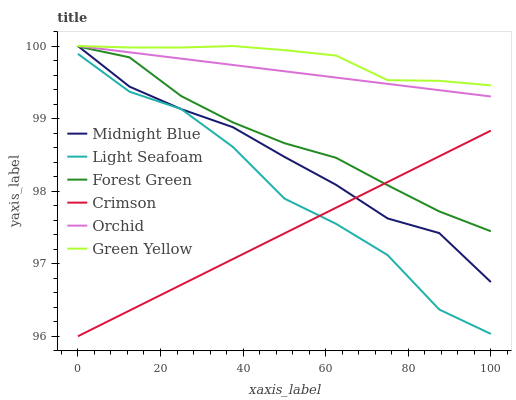Does Crimson have the minimum area under the curve?
Answer yes or no. Yes. Does Green Yellow have the maximum area under the curve?
Answer yes or no. Yes. Does Midnight Blue have the minimum area under the curve?
Answer yes or no. No. Does Midnight Blue have the maximum area under the curve?
Answer yes or no. No. Is Crimson the smoothest?
Answer yes or no. Yes. Is Light Seafoam the roughest?
Answer yes or no. Yes. Is Midnight Blue the smoothest?
Answer yes or no. No. Is Midnight Blue the roughest?
Answer yes or no. No. Does Crimson have the lowest value?
Answer yes or no. Yes. Does Midnight Blue have the lowest value?
Answer yes or no. No. Does Orchid have the highest value?
Answer yes or no. Yes. Does Forest Green have the highest value?
Answer yes or no. No. Is Light Seafoam less than Green Yellow?
Answer yes or no. Yes. Is Green Yellow greater than Light Seafoam?
Answer yes or no. Yes. Does Midnight Blue intersect Forest Green?
Answer yes or no. Yes. Is Midnight Blue less than Forest Green?
Answer yes or no. No. Is Midnight Blue greater than Forest Green?
Answer yes or no. No. Does Light Seafoam intersect Green Yellow?
Answer yes or no. No. 